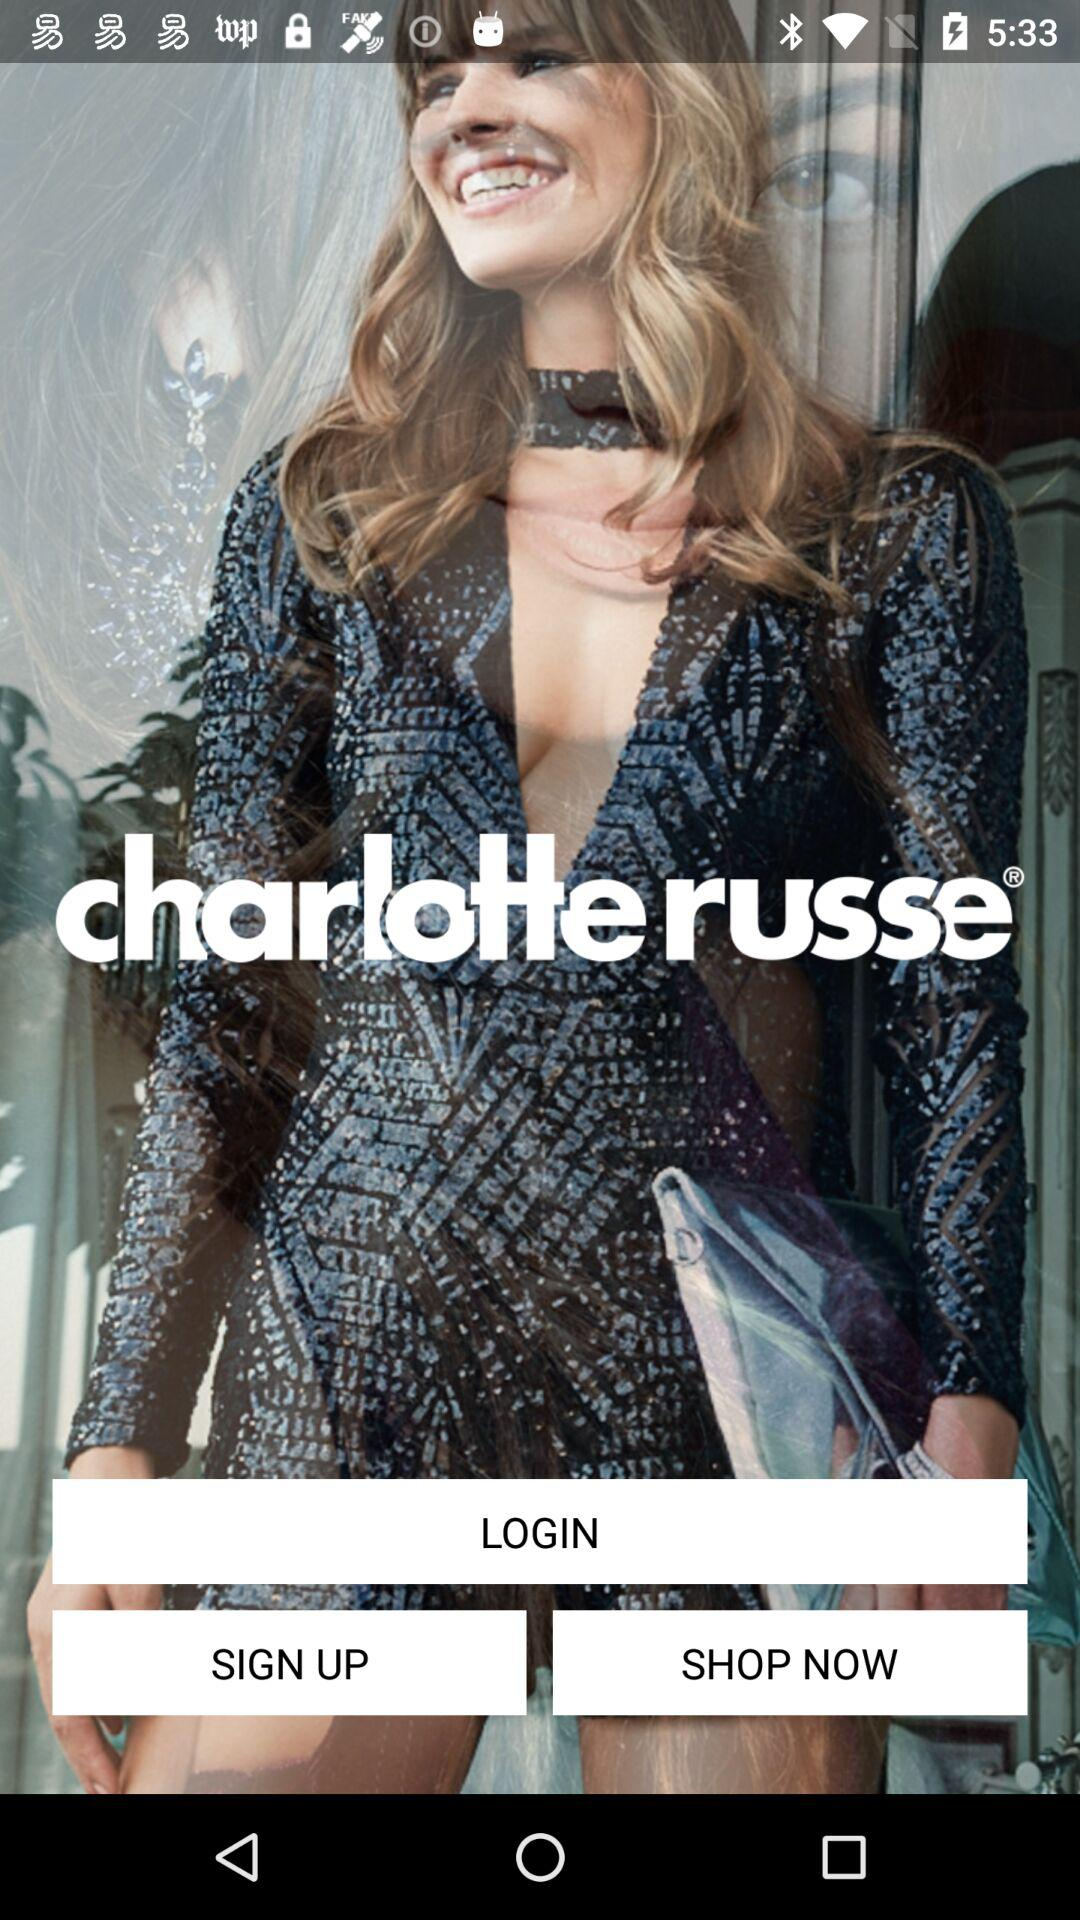What is the name of the application? The name of the application is "charlotte russe". 